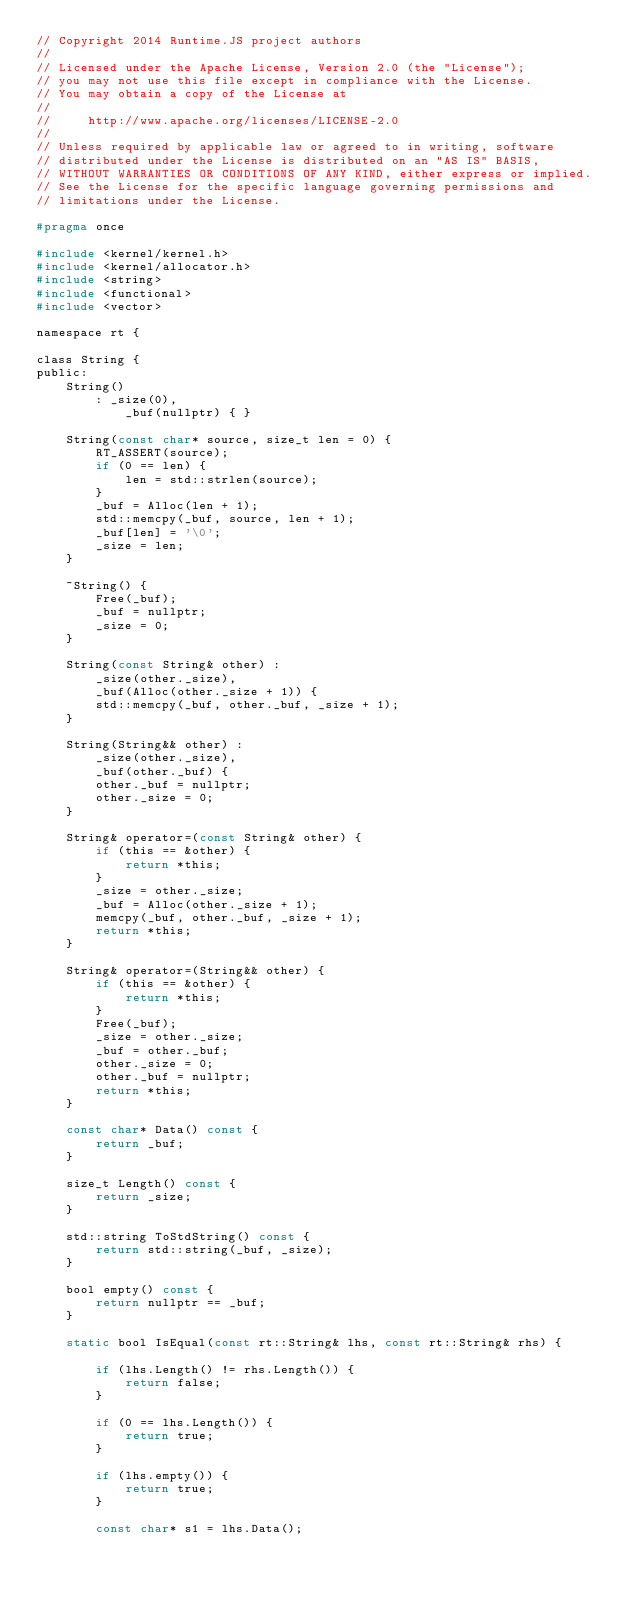Convert code to text. <code><loc_0><loc_0><loc_500><loc_500><_C_>// Copyright 2014 Runtime.JS project authors
//
// Licensed under the Apache License, Version 2.0 (the "License");
// you may not use this file except in compliance with the License.
// You may obtain a copy of the License at
//
//     http://www.apache.org/licenses/LICENSE-2.0
//
// Unless required by applicable law or agreed to in writing, software
// distributed under the License is distributed on an "AS IS" BASIS,
// WITHOUT WARRANTIES OR CONDITIONS OF ANY KIND, either express or implied.
// See the License for the specific language governing permissions and
// limitations under the License.

#pragma once

#include <kernel/kernel.h>
#include <kernel/allocator.h>
#include <string>
#include <functional>
#include <vector>

namespace rt {

class String {
public:
    String()
        :	_size(0),
            _buf(nullptr) { }

    String(const char* source, size_t len = 0) {
        RT_ASSERT(source);
        if (0 == len) {
            len = std::strlen(source);
        }
        _buf = Alloc(len + 1);
        std::memcpy(_buf, source, len + 1);
        _buf[len] = '\0';
        _size = len;
    }

    ~String() {
        Free(_buf);
        _buf = nullptr;
        _size = 0;
    }

    String(const String& other) :
        _size(other._size),
        _buf(Alloc(other._size + 1)) {
        std::memcpy(_buf, other._buf, _size + 1);
    }

    String(String&& other) :
        _size(other._size),
        _buf(other._buf) {
        other._buf = nullptr;
        other._size = 0;
    }

    String& operator=(const String& other) {
        if (this == &other) {
            return *this;
        }
        _size = other._size;
        _buf = Alloc(other._size + 1);
        memcpy(_buf, other._buf, _size + 1);
        return *this;
    }

    String& operator=(String&& other) {
        if (this == &other) {
            return *this;
        }
        Free(_buf);
        _size = other._size;
        _buf = other._buf;
        other._size = 0;
        other._buf = nullptr;
        return *this;
    }

    const char* Data() const {
        return _buf;
    }

    size_t Length() const {
        return _size;
    }

    std::string ToStdString() const {
        return std::string(_buf, _size);
    }

    bool empty() const {
        return nullptr == _buf;
    }

    static bool IsEqual(const rt::String& lhs, const rt::String& rhs) {

        if (lhs.Length() != rhs.Length()) {
            return false;
        }

        if (0 == lhs.Length()) {
            return true;
        }

        if (lhs.empty()) {
            return true;
        }

        const char* s1 = lhs.Data();</code> 